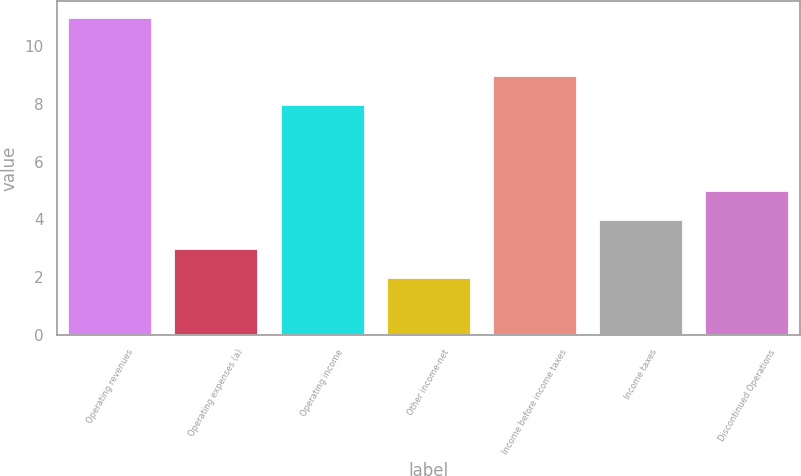<chart> <loc_0><loc_0><loc_500><loc_500><bar_chart><fcel>Operating revenues<fcel>Operating expenses (a)<fcel>Operating income<fcel>Other income-net<fcel>Income before income taxes<fcel>Income taxes<fcel>Discontinued Operations<nl><fcel>11<fcel>3<fcel>8<fcel>2<fcel>9<fcel>4<fcel>5<nl></chart> 